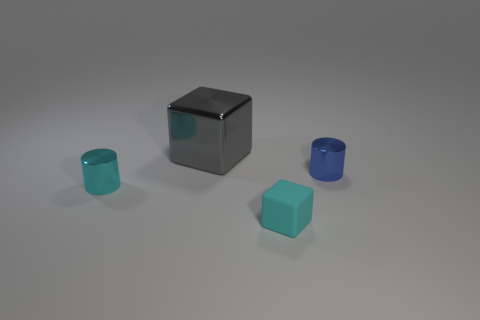How big is the object that is both on the right side of the big gray cube and behind the tiny rubber object?
Offer a terse response. Small. How many cyan shiny cylinders are there?
Keep it short and to the point. 1. There is a cube that is the same size as the cyan shiny cylinder; what material is it?
Your response must be concise. Rubber. Are there any gray metal blocks of the same size as the gray metallic object?
Your answer should be compact. No. There is a metallic cylinder on the left side of the tiny matte thing; is it the same color as the cylinder right of the metallic block?
Your response must be concise. No. How many matte things are cyan things or big purple cylinders?
Provide a succinct answer. 1. What number of tiny blue metal cylinders are behind the block behind the metallic object right of the small cyan matte object?
Provide a succinct answer. 0. There is a cylinder that is the same material as the blue object; what is its size?
Provide a short and direct response. Small. How many rubber things have the same color as the matte cube?
Keep it short and to the point. 0. There is a cylinder behind the cyan shiny cylinder; is its size the same as the rubber block?
Provide a succinct answer. Yes. 